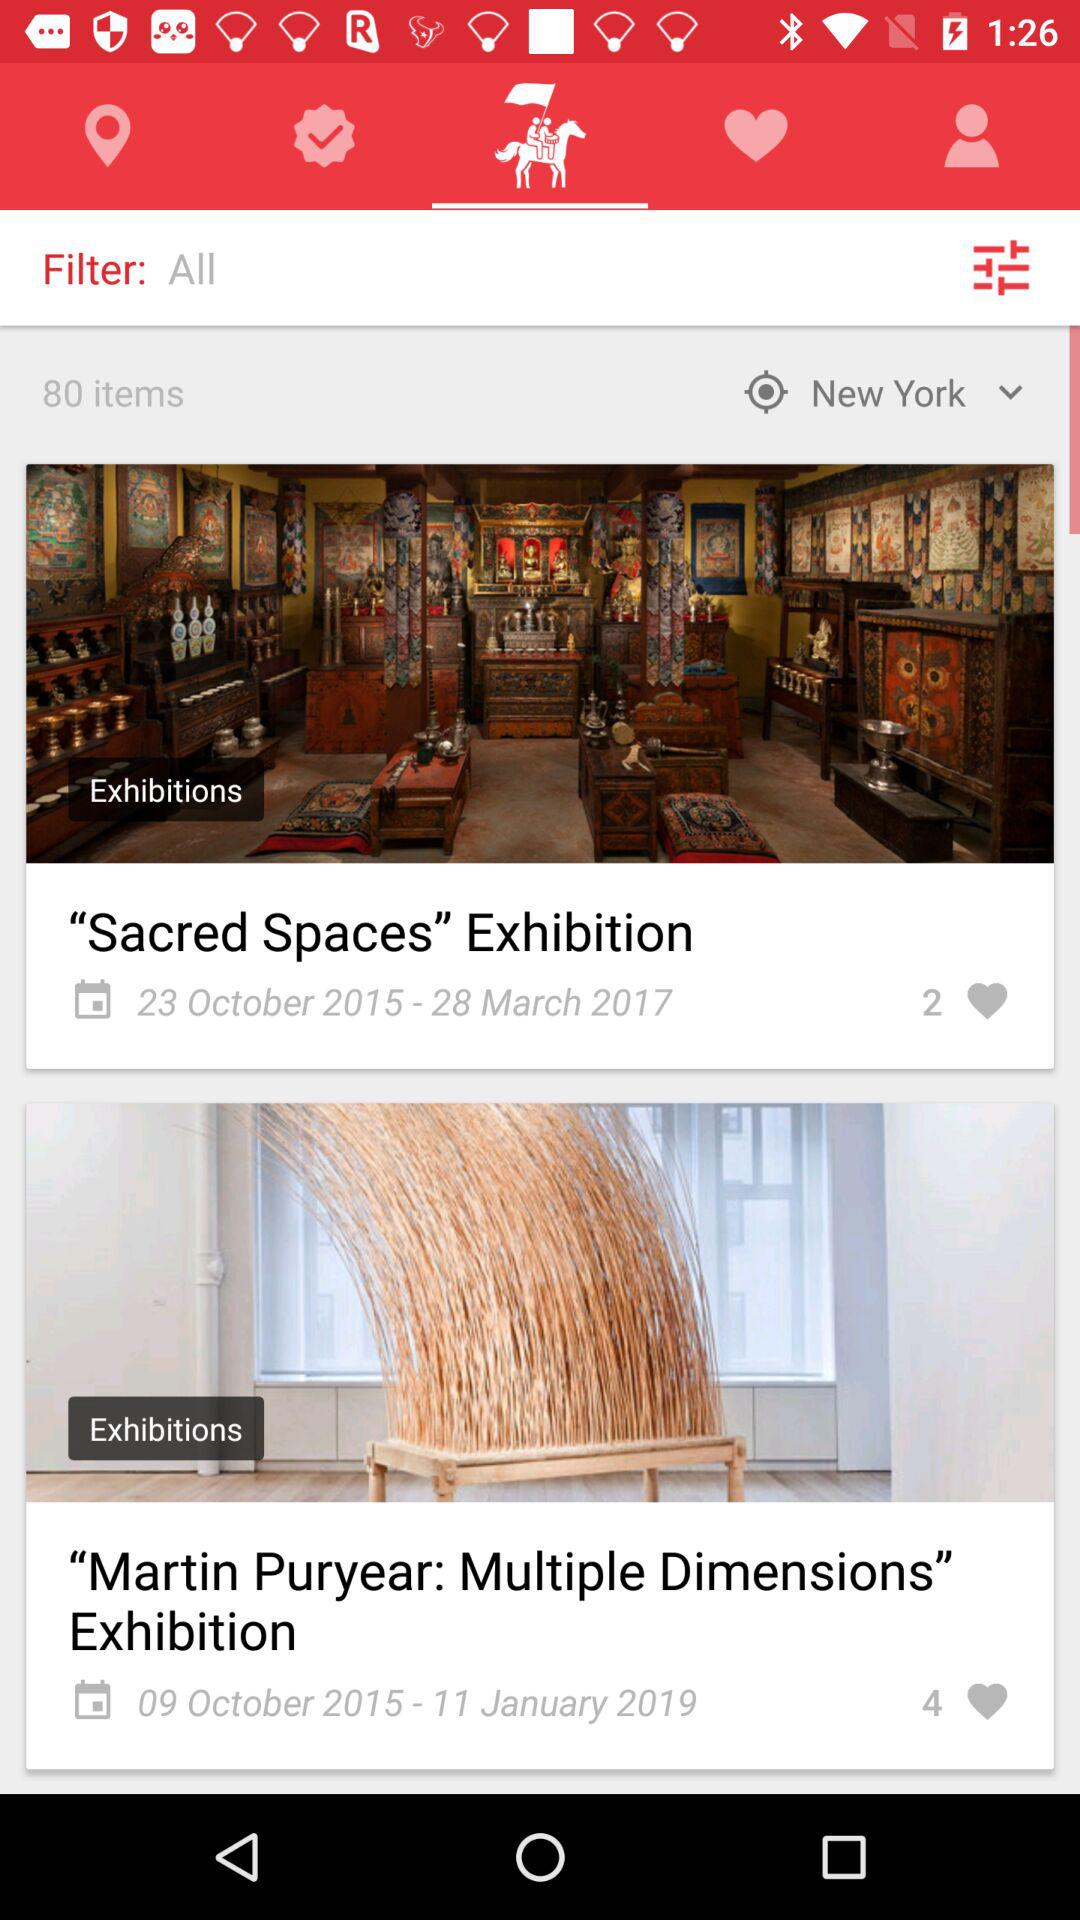How many likes are on the "Sacred Spaces" exhibition? There are 2 likes. 